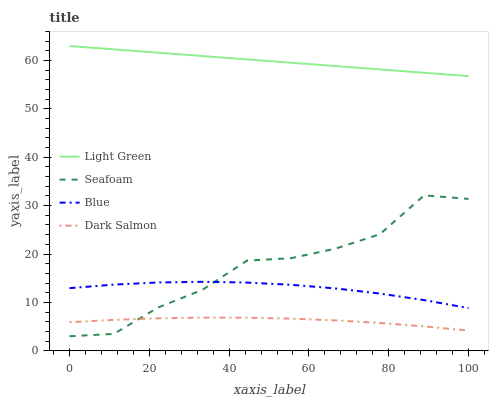Does Seafoam have the minimum area under the curve?
Answer yes or no. No. Does Seafoam have the maximum area under the curve?
Answer yes or no. No. Is Seafoam the smoothest?
Answer yes or no. No. Is Light Green the roughest?
Answer yes or no. No. Does Light Green have the lowest value?
Answer yes or no. No. Does Seafoam have the highest value?
Answer yes or no. No. Is Seafoam less than Light Green?
Answer yes or no. Yes. Is Light Green greater than Blue?
Answer yes or no. Yes. Does Seafoam intersect Light Green?
Answer yes or no. No. 